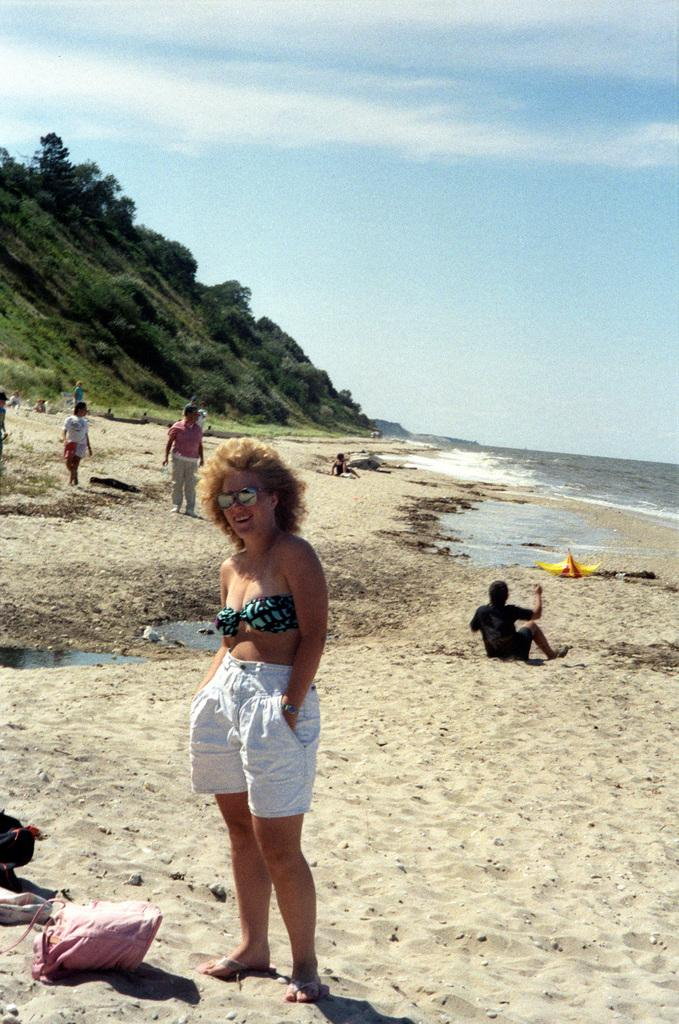What are the people in the image doing? The people in the image are standing and sitting on the seashore. What might indicate that the people are on a trip or vacation? The presence of luggage visible in the image suggests that the people might be on a trip or vacation. What can be seen in the background of the image? There are trees, mountains, and the sky visible in the background of the image. What type of rose is being used as a tablecloth in the image? There is no rose present in the image, nor is there a tablecloth. What meal is being prepared on the pump in the image? There is no pump or meal preparation visible in the image. 